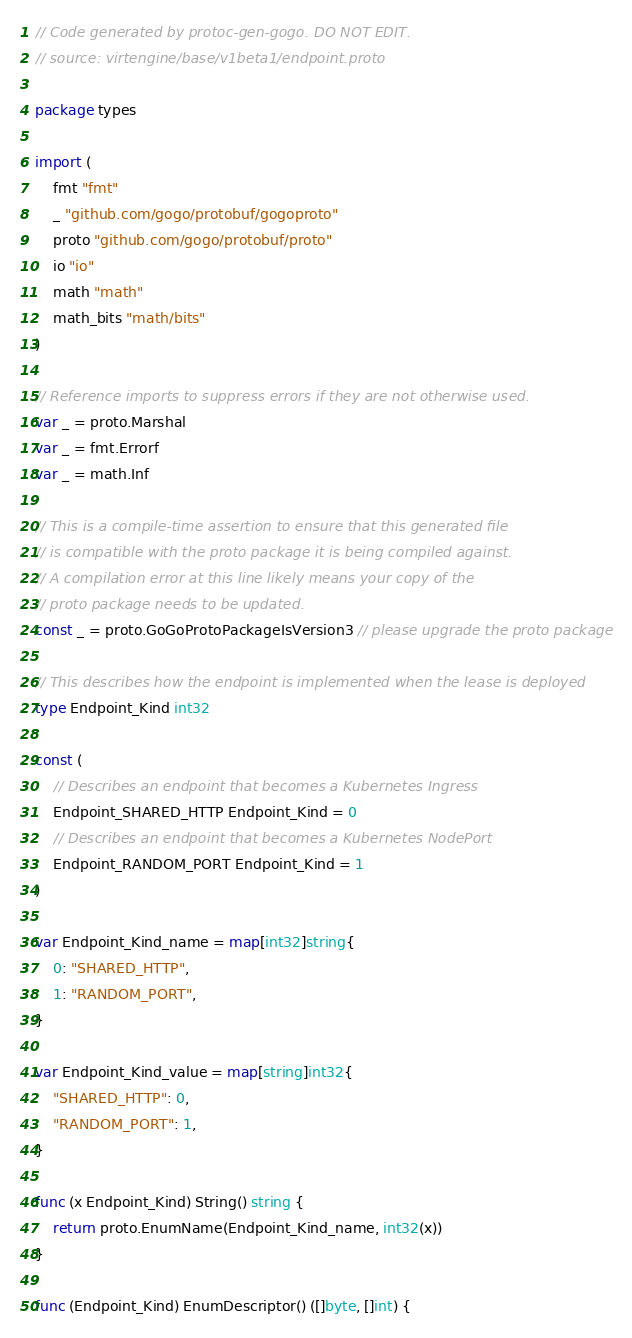<code> <loc_0><loc_0><loc_500><loc_500><_Go_>// Code generated by protoc-gen-gogo. DO NOT EDIT.
// source: virtengine/base/v1beta1/endpoint.proto

package types

import (
	fmt "fmt"
	_ "github.com/gogo/protobuf/gogoproto"
	proto "github.com/gogo/protobuf/proto"
	io "io"
	math "math"
	math_bits "math/bits"
)

// Reference imports to suppress errors if they are not otherwise used.
var _ = proto.Marshal
var _ = fmt.Errorf
var _ = math.Inf

// This is a compile-time assertion to ensure that this generated file
// is compatible with the proto package it is being compiled against.
// A compilation error at this line likely means your copy of the
// proto package needs to be updated.
const _ = proto.GoGoProtoPackageIsVersion3 // please upgrade the proto package

// This describes how the endpoint is implemented when the lease is deployed
type Endpoint_Kind int32

const (
	// Describes an endpoint that becomes a Kubernetes Ingress
	Endpoint_SHARED_HTTP Endpoint_Kind = 0
	// Describes an endpoint that becomes a Kubernetes NodePort
	Endpoint_RANDOM_PORT Endpoint_Kind = 1
)

var Endpoint_Kind_name = map[int32]string{
	0: "SHARED_HTTP",
	1: "RANDOM_PORT",
}

var Endpoint_Kind_value = map[string]int32{
	"SHARED_HTTP": 0,
	"RANDOM_PORT": 1,
}

func (x Endpoint_Kind) String() string {
	return proto.EnumName(Endpoint_Kind_name, int32(x))
}

func (Endpoint_Kind) EnumDescriptor() ([]byte, []int) {</code> 